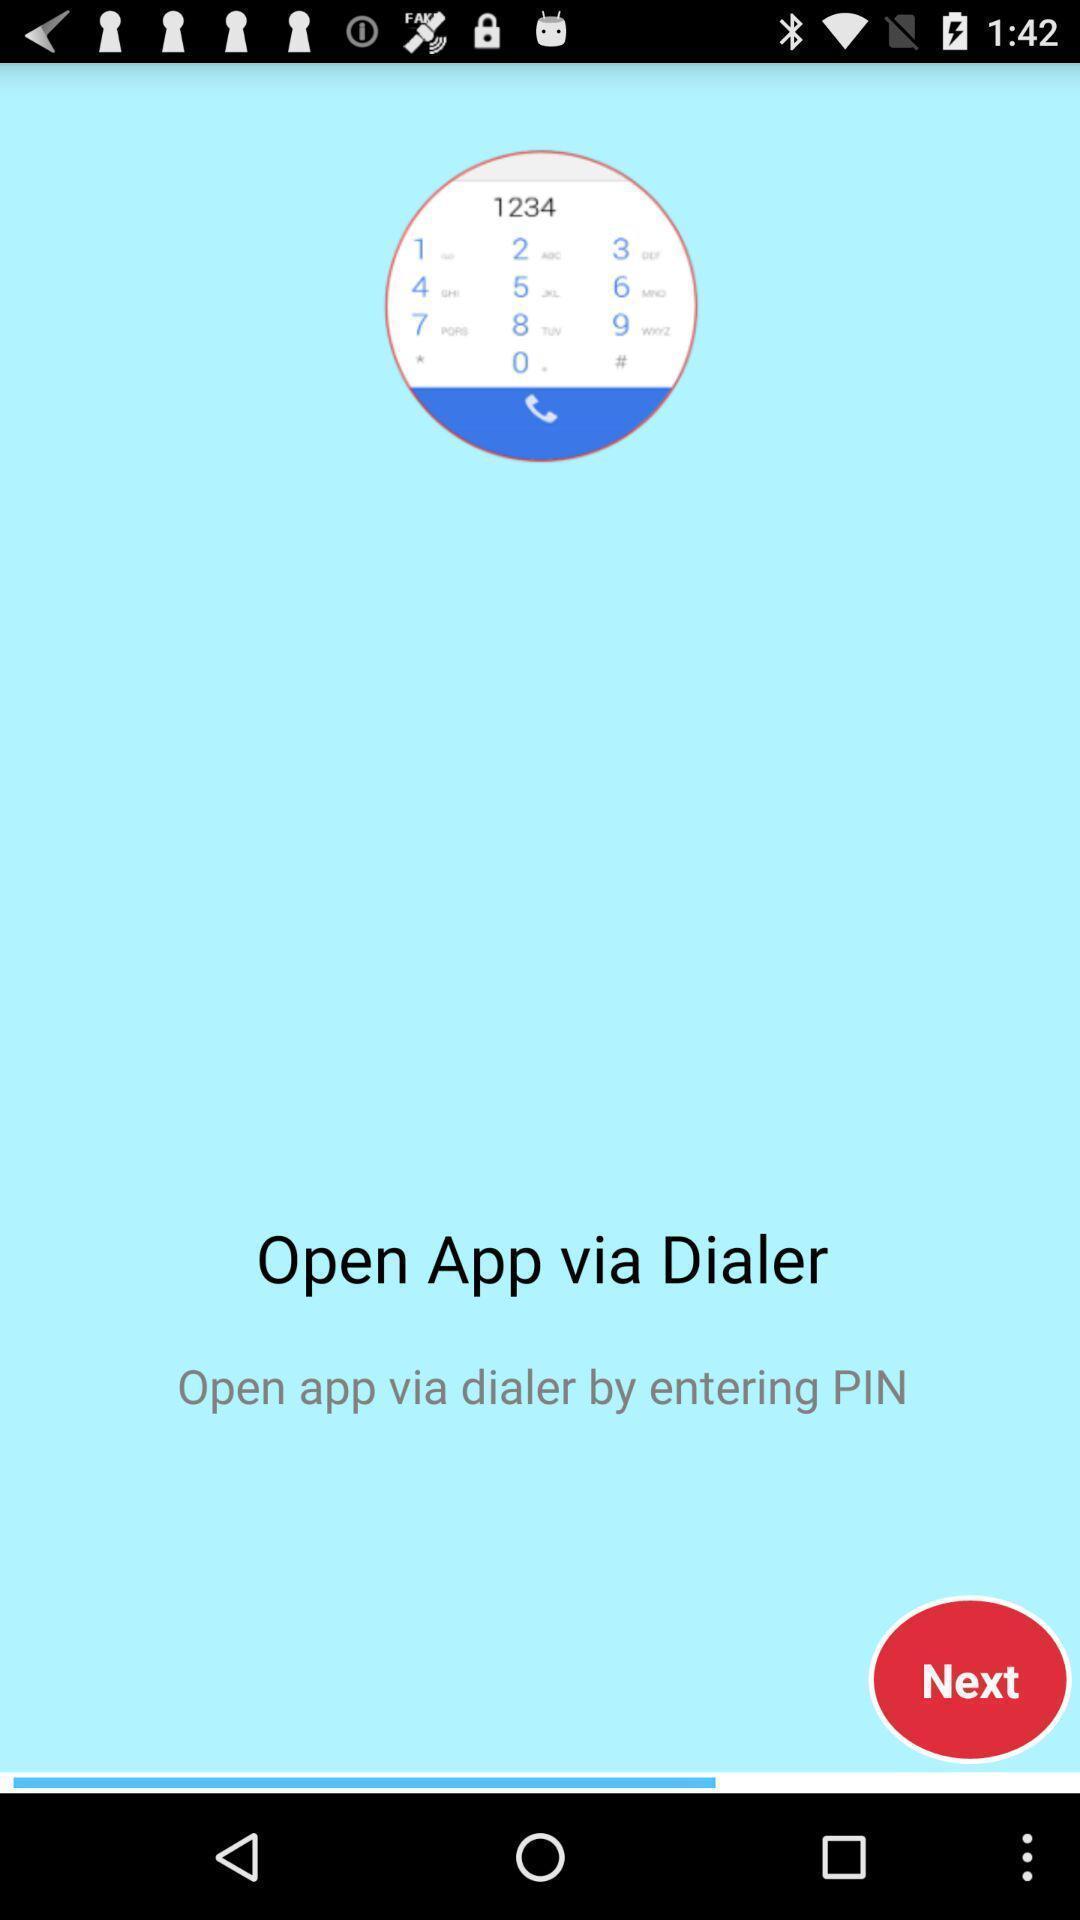Describe this image in words. Welcome page of a social app. 